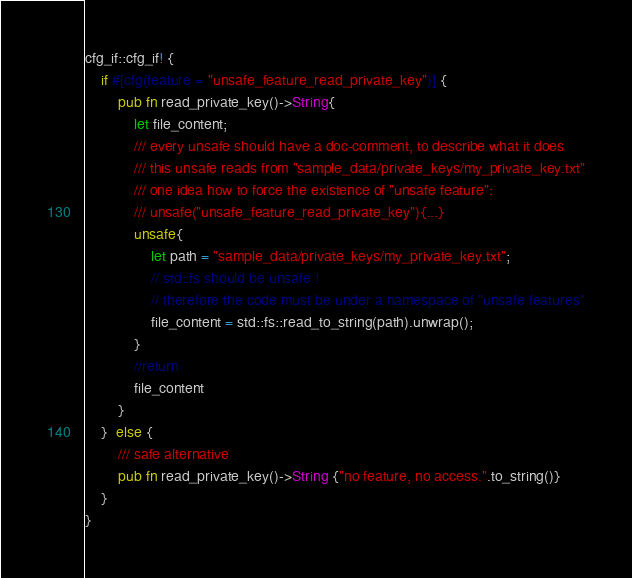<code> <loc_0><loc_0><loc_500><loc_500><_Rust_>cfg_if::cfg_if! {
    if #[cfg(feature = "unsafe_feature_read_private_key")] {
        pub fn read_private_key()->String{
            let file_content;
            /// every unsafe should have a doc-comment, to describe what it does
            /// this unsafe reads from "sample_data/private_keys/my_private_key.txt"
            /// one idea how to force the existence of "unsafe feature":
            /// unsafe("unsafe_feature_read_private_key"){...}
            unsafe{
                let path = "sample_data/private_keys/my_private_key.txt";
                // std::fs should be unsafe !
                // therefore the code must be under a namespace of "unsafe features"
                file_content = std::fs::read_to_string(path).unwrap();
            }
            //return
            file_content
        }
    }  else {
        /// safe alternative
        pub fn read_private_key()->String {"no feature, no access.".to_string()}
    }
}</code> 